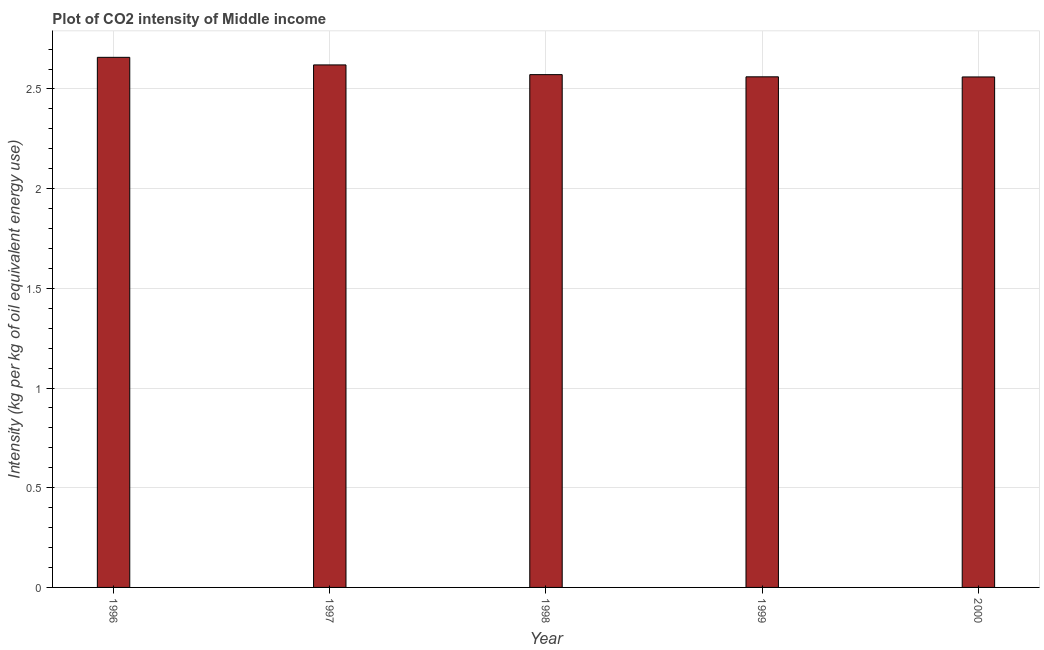Does the graph contain grids?
Keep it short and to the point. Yes. What is the title of the graph?
Offer a terse response. Plot of CO2 intensity of Middle income. What is the label or title of the X-axis?
Give a very brief answer. Year. What is the label or title of the Y-axis?
Keep it short and to the point. Intensity (kg per kg of oil equivalent energy use). What is the co2 intensity in 1999?
Keep it short and to the point. 2.56. Across all years, what is the maximum co2 intensity?
Your response must be concise. 2.66. Across all years, what is the minimum co2 intensity?
Provide a short and direct response. 2.56. In which year was the co2 intensity maximum?
Offer a very short reply. 1996. What is the sum of the co2 intensity?
Your response must be concise. 12.97. What is the difference between the co2 intensity in 1996 and 1999?
Your answer should be compact. 0.1. What is the average co2 intensity per year?
Your response must be concise. 2.6. What is the median co2 intensity?
Offer a terse response. 2.57. In how many years, is the co2 intensity greater than 1 kg?
Give a very brief answer. 5. Is the co2 intensity in 1998 less than that in 2000?
Give a very brief answer. No. What is the difference between the highest and the second highest co2 intensity?
Your response must be concise. 0.04. Is the sum of the co2 intensity in 1997 and 1999 greater than the maximum co2 intensity across all years?
Offer a terse response. Yes. What is the difference between the highest and the lowest co2 intensity?
Keep it short and to the point. 0.1. In how many years, is the co2 intensity greater than the average co2 intensity taken over all years?
Keep it short and to the point. 2. How many years are there in the graph?
Keep it short and to the point. 5. What is the difference between two consecutive major ticks on the Y-axis?
Make the answer very short. 0.5. Are the values on the major ticks of Y-axis written in scientific E-notation?
Provide a succinct answer. No. What is the Intensity (kg per kg of oil equivalent energy use) of 1996?
Provide a short and direct response. 2.66. What is the Intensity (kg per kg of oil equivalent energy use) of 1997?
Ensure brevity in your answer.  2.62. What is the Intensity (kg per kg of oil equivalent energy use) in 1998?
Make the answer very short. 2.57. What is the Intensity (kg per kg of oil equivalent energy use) of 1999?
Offer a terse response. 2.56. What is the Intensity (kg per kg of oil equivalent energy use) in 2000?
Ensure brevity in your answer.  2.56. What is the difference between the Intensity (kg per kg of oil equivalent energy use) in 1996 and 1997?
Your answer should be compact. 0.04. What is the difference between the Intensity (kg per kg of oil equivalent energy use) in 1996 and 1998?
Your answer should be compact. 0.09. What is the difference between the Intensity (kg per kg of oil equivalent energy use) in 1996 and 1999?
Provide a short and direct response. 0.1. What is the difference between the Intensity (kg per kg of oil equivalent energy use) in 1996 and 2000?
Give a very brief answer. 0.1. What is the difference between the Intensity (kg per kg of oil equivalent energy use) in 1997 and 1998?
Offer a terse response. 0.05. What is the difference between the Intensity (kg per kg of oil equivalent energy use) in 1997 and 1999?
Make the answer very short. 0.06. What is the difference between the Intensity (kg per kg of oil equivalent energy use) in 1997 and 2000?
Your answer should be very brief. 0.06. What is the difference between the Intensity (kg per kg of oil equivalent energy use) in 1998 and 1999?
Provide a succinct answer. 0.01. What is the difference between the Intensity (kg per kg of oil equivalent energy use) in 1998 and 2000?
Your answer should be very brief. 0.01. What is the difference between the Intensity (kg per kg of oil equivalent energy use) in 1999 and 2000?
Your response must be concise. 0. What is the ratio of the Intensity (kg per kg of oil equivalent energy use) in 1996 to that in 1997?
Offer a terse response. 1.01. What is the ratio of the Intensity (kg per kg of oil equivalent energy use) in 1996 to that in 1998?
Provide a succinct answer. 1.03. What is the ratio of the Intensity (kg per kg of oil equivalent energy use) in 1996 to that in 1999?
Provide a short and direct response. 1.04. What is the ratio of the Intensity (kg per kg of oil equivalent energy use) in 1996 to that in 2000?
Offer a terse response. 1.04. What is the ratio of the Intensity (kg per kg of oil equivalent energy use) in 1997 to that in 1998?
Provide a succinct answer. 1.02. What is the ratio of the Intensity (kg per kg of oil equivalent energy use) in 1997 to that in 1999?
Your answer should be very brief. 1.02. What is the ratio of the Intensity (kg per kg of oil equivalent energy use) in 1997 to that in 2000?
Your answer should be very brief. 1.02. What is the ratio of the Intensity (kg per kg of oil equivalent energy use) in 1998 to that in 1999?
Offer a terse response. 1. 